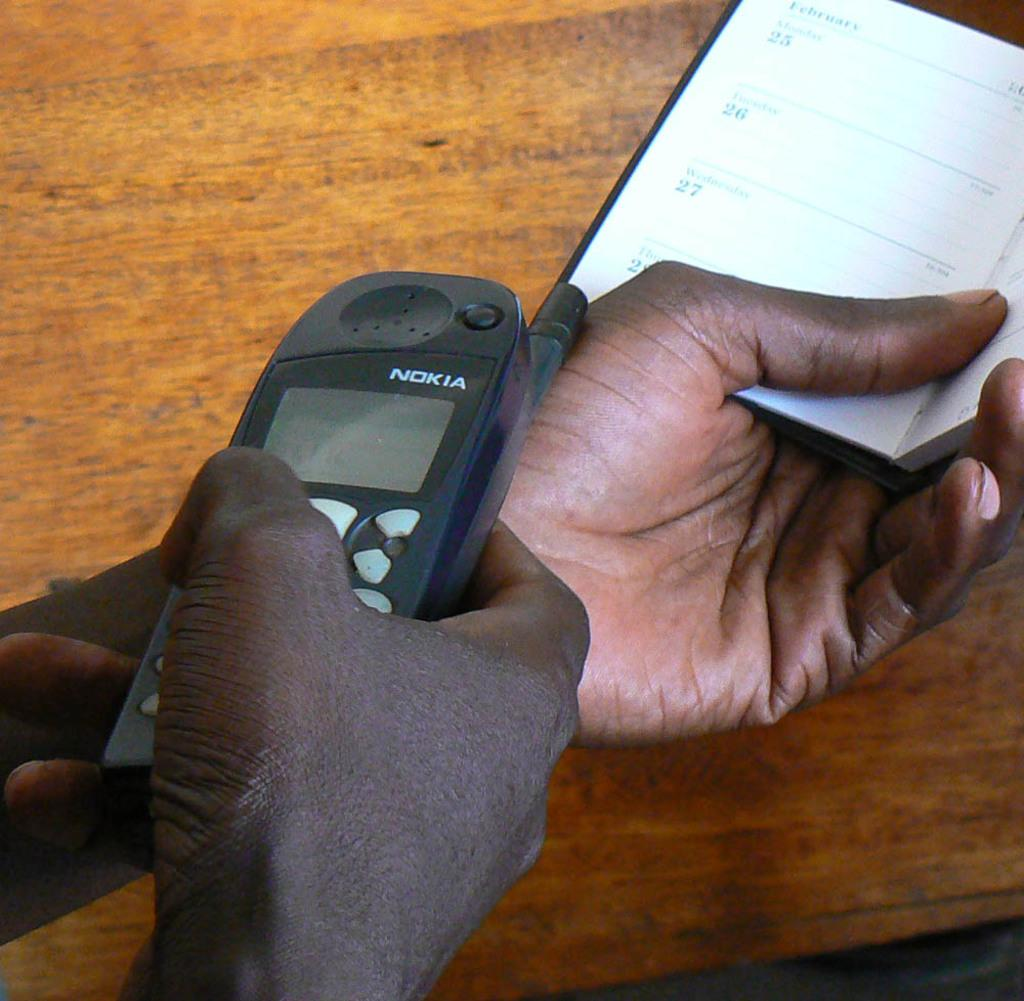<image>
Create a compact narrative representing the image presented. The man is holding a date book and a Nokia brand phone. 